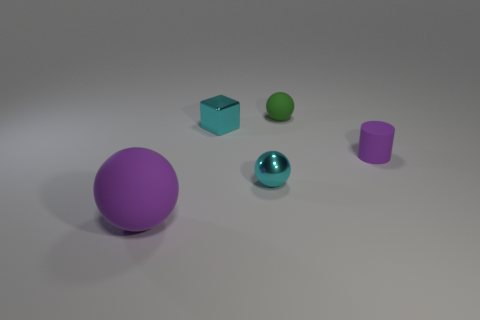Subtract all purple spheres. How many spheres are left? 2 Subtract 1 spheres. How many spheres are left? 2 Add 1 cyan cylinders. How many objects exist? 6 Subtract all spheres. How many objects are left? 2 Subtract 0 blue balls. How many objects are left? 5 Subtract all blue cylinders. Subtract all gray balls. How many cylinders are left? 1 Subtract all green objects. Subtract all tiny purple rubber cylinders. How many objects are left? 3 Add 5 tiny green matte spheres. How many tiny green matte spheres are left? 6 Add 3 yellow metallic blocks. How many yellow metallic blocks exist? 3 